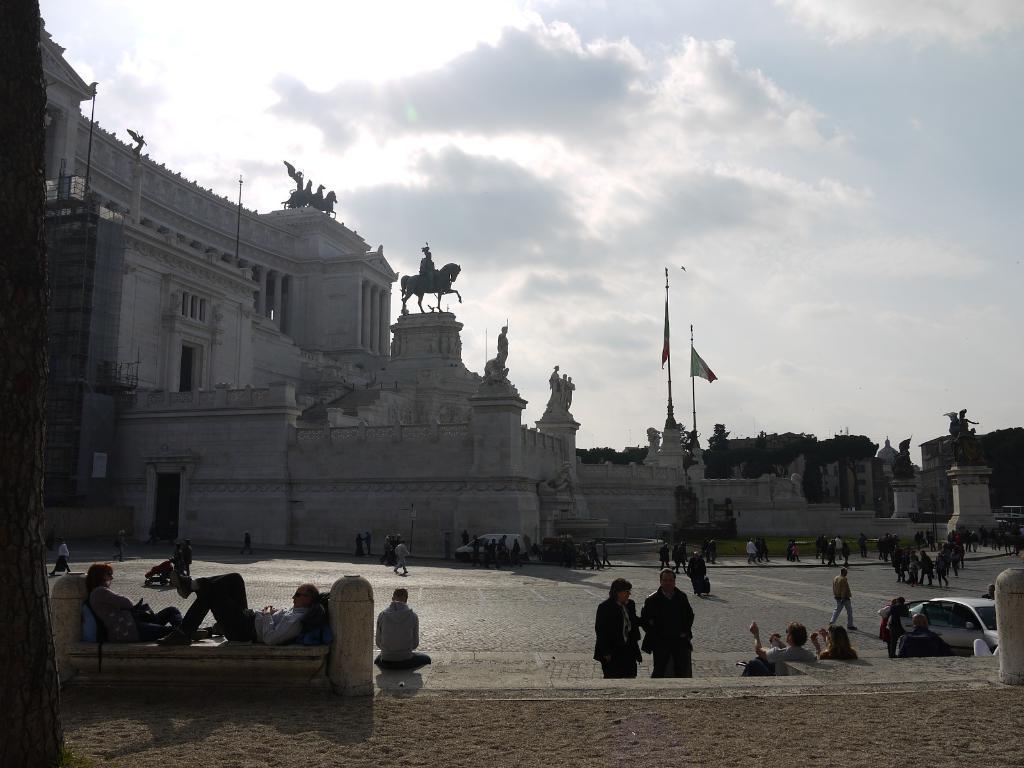In one or two sentences, can you explain what this image depicts? This picture is clicked in the historical place. In the middle of the picture, we see many people walking and standing on the road. AT the bottom of the picture, we see sand and two people are lying on the bench. In the right bottom of the picture, we see the car parked on the road. Beside these people, we see a building in white color. We even see flags. There are trees in the background. At the top of the picture, we see the sky and the sun. 